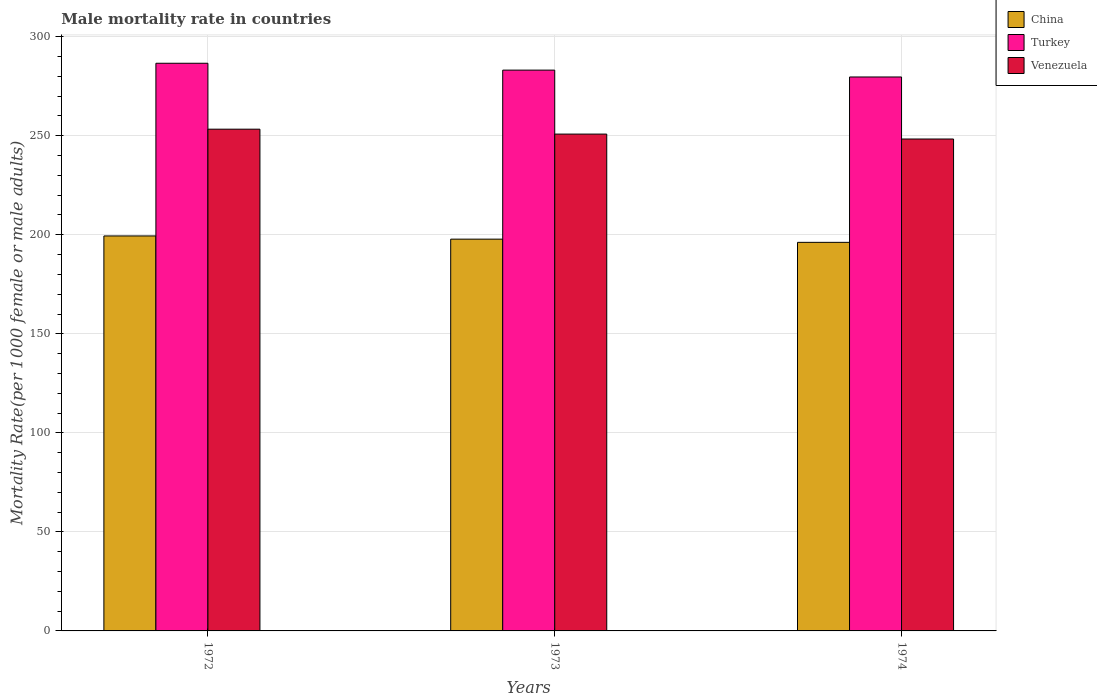Are the number of bars per tick equal to the number of legend labels?
Your response must be concise. Yes. Are the number of bars on each tick of the X-axis equal?
Your answer should be compact. Yes. How many bars are there on the 3rd tick from the left?
Provide a succinct answer. 3. What is the label of the 2nd group of bars from the left?
Your answer should be very brief. 1973. What is the male mortality rate in Turkey in 1974?
Your answer should be very brief. 279.67. Across all years, what is the maximum male mortality rate in Venezuela?
Ensure brevity in your answer.  253.31. Across all years, what is the minimum male mortality rate in China?
Your answer should be compact. 196.17. In which year was the male mortality rate in Turkey minimum?
Provide a succinct answer. 1974. What is the total male mortality rate in Venezuela in the graph?
Keep it short and to the point. 752.48. What is the difference between the male mortality rate in Venezuela in 1973 and that in 1974?
Give a very brief answer. 2.48. What is the difference between the male mortality rate in China in 1973 and the male mortality rate in Venezuela in 1974?
Ensure brevity in your answer.  -50.56. What is the average male mortality rate in China per year?
Your answer should be compact. 197.79. In the year 1973, what is the difference between the male mortality rate in Venezuela and male mortality rate in Turkey?
Provide a succinct answer. -32.3. In how many years, is the male mortality rate in Venezuela greater than 190?
Keep it short and to the point. 3. What is the ratio of the male mortality rate in China in 1973 to that in 1974?
Your answer should be very brief. 1.01. Is the difference between the male mortality rate in Venezuela in 1972 and 1973 greater than the difference between the male mortality rate in Turkey in 1972 and 1973?
Make the answer very short. No. What is the difference between the highest and the second highest male mortality rate in China?
Keep it short and to the point. 1.62. What is the difference between the highest and the lowest male mortality rate in Venezuela?
Make the answer very short. 4.96. What does the 3rd bar from the left in 1972 represents?
Offer a very short reply. Venezuela. What does the 1st bar from the right in 1973 represents?
Offer a terse response. Venezuela. Are the values on the major ticks of Y-axis written in scientific E-notation?
Provide a short and direct response. No. Does the graph contain any zero values?
Provide a succinct answer. No. Does the graph contain grids?
Your answer should be compact. Yes. Where does the legend appear in the graph?
Keep it short and to the point. Top right. How many legend labels are there?
Your response must be concise. 3. What is the title of the graph?
Your response must be concise. Male mortality rate in countries. Does "Korea (Democratic)" appear as one of the legend labels in the graph?
Offer a very short reply. No. What is the label or title of the Y-axis?
Make the answer very short. Mortality Rate(per 1000 female or male adults). What is the Mortality Rate(per 1000 female or male adults) in China in 1972?
Your answer should be compact. 199.41. What is the Mortality Rate(per 1000 female or male adults) of Turkey in 1972?
Your response must be concise. 286.59. What is the Mortality Rate(per 1000 female or male adults) of Venezuela in 1972?
Your response must be concise. 253.31. What is the Mortality Rate(per 1000 female or male adults) in China in 1973?
Offer a very short reply. 197.79. What is the Mortality Rate(per 1000 female or male adults) in Turkey in 1973?
Offer a very short reply. 283.13. What is the Mortality Rate(per 1000 female or male adults) in Venezuela in 1973?
Provide a succinct answer. 250.83. What is the Mortality Rate(per 1000 female or male adults) of China in 1974?
Your response must be concise. 196.17. What is the Mortality Rate(per 1000 female or male adults) of Turkey in 1974?
Make the answer very short. 279.67. What is the Mortality Rate(per 1000 female or male adults) of Venezuela in 1974?
Your answer should be very brief. 248.35. Across all years, what is the maximum Mortality Rate(per 1000 female or male adults) of China?
Your answer should be compact. 199.41. Across all years, what is the maximum Mortality Rate(per 1000 female or male adults) of Turkey?
Your answer should be very brief. 286.59. Across all years, what is the maximum Mortality Rate(per 1000 female or male adults) of Venezuela?
Your response must be concise. 253.31. Across all years, what is the minimum Mortality Rate(per 1000 female or male adults) in China?
Your answer should be very brief. 196.17. Across all years, what is the minimum Mortality Rate(per 1000 female or male adults) in Turkey?
Your response must be concise. 279.67. Across all years, what is the minimum Mortality Rate(per 1000 female or male adults) of Venezuela?
Your response must be concise. 248.35. What is the total Mortality Rate(per 1000 female or male adults) in China in the graph?
Your response must be concise. 593.38. What is the total Mortality Rate(per 1000 female or male adults) in Turkey in the graph?
Your response must be concise. 849.38. What is the total Mortality Rate(per 1000 female or male adults) in Venezuela in the graph?
Your response must be concise. 752.48. What is the difference between the Mortality Rate(per 1000 female or male adults) of China in 1972 and that in 1973?
Your answer should be very brief. 1.62. What is the difference between the Mortality Rate(per 1000 female or male adults) in Turkey in 1972 and that in 1973?
Your answer should be very brief. 3.46. What is the difference between the Mortality Rate(per 1000 female or male adults) in Venezuela in 1972 and that in 1973?
Provide a succinct answer. 2.48. What is the difference between the Mortality Rate(per 1000 female or male adults) of China in 1972 and that in 1974?
Ensure brevity in your answer.  3.24. What is the difference between the Mortality Rate(per 1000 female or male adults) of Turkey in 1972 and that in 1974?
Your response must be concise. 6.92. What is the difference between the Mortality Rate(per 1000 female or male adults) of Venezuela in 1972 and that in 1974?
Keep it short and to the point. 4.96. What is the difference between the Mortality Rate(per 1000 female or male adults) in China in 1973 and that in 1974?
Keep it short and to the point. 1.62. What is the difference between the Mortality Rate(per 1000 female or male adults) in Turkey in 1973 and that in 1974?
Give a very brief answer. 3.46. What is the difference between the Mortality Rate(per 1000 female or male adults) of Venezuela in 1973 and that in 1974?
Provide a succinct answer. 2.48. What is the difference between the Mortality Rate(per 1000 female or male adults) in China in 1972 and the Mortality Rate(per 1000 female or male adults) in Turkey in 1973?
Provide a short and direct response. -83.72. What is the difference between the Mortality Rate(per 1000 female or male adults) in China in 1972 and the Mortality Rate(per 1000 female or male adults) in Venezuela in 1973?
Keep it short and to the point. -51.42. What is the difference between the Mortality Rate(per 1000 female or male adults) of Turkey in 1972 and the Mortality Rate(per 1000 female or male adults) of Venezuela in 1973?
Ensure brevity in your answer.  35.76. What is the difference between the Mortality Rate(per 1000 female or male adults) in China in 1972 and the Mortality Rate(per 1000 female or male adults) in Turkey in 1974?
Your answer should be compact. -80.26. What is the difference between the Mortality Rate(per 1000 female or male adults) in China in 1972 and the Mortality Rate(per 1000 female or male adults) in Venezuela in 1974?
Your answer should be compact. -48.94. What is the difference between the Mortality Rate(per 1000 female or male adults) in Turkey in 1972 and the Mortality Rate(per 1000 female or male adults) in Venezuela in 1974?
Provide a short and direct response. 38.24. What is the difference between the Mortality Rate(per 1000 female or male adults) in China in 1973 and the Mortality Rate(per 1000 female or male adults) in Turkey in 1974?
Keep it short and to the point. -81.87. What is the difference between the Mortality Rate(per 1000 female or male adults) in China in 1973 and the Mortality Rate(per 1000 female or male adults) in Venezuela in 1974?
Provide a short and direct response. -50.56. What is the difference between the Mortality Rate(per 1000 female or male adults) of Turkey in 1973 and the Mortality Rate(per 1000 female or male adults) of Venezuela in 1974?
Ensure brevity in your answer.  34.78. What is the average Mortality Rate(per 1000 female or male adults) of China per year?
Your answer should be very brief. 197.79. What is the average Mortality Rate(per 1000 female or male adults) of Turkey per year?
Give a very brief answer. 283.13. What is the average Mortality Rate(per 1000 female or male adults) of Venezuela per year?
Give a very brief answer. 250.83. In the year 1972, what is the difference between the Mortality Rate(per 1000 female or male adults) of China and Mortality Rate(per 1000 female or male adults) of Turkey?
Your response must be concise. -87.18. In the year 1972, what is the difference between the Mortality Rate(per 1000 female or male adults) of China and Mortality Rate(per 1000 female or male adults) of Venezuela?
Provide a short and direct response. -53.9. In the year 1972, what is the difference between the Mortality Rate(per 1000 female or male adults) in Turkey and Mortality Rate(per 1000 female or male adults) in Venezuela?
Provide a short and direct response. 33.28. In the year 1973, what is the difference between the Mortality Rate(per 1000 female or male adults) in China and Mortality Rate(per 1000 female or male adults) in Turkey?
Provide a succinct answer. -85.34. In the year 1973, what is the difference between the Mortality Rate(per 1000 female or male adults) of China and Mortality Rate(per 1000 female or male adults) of Venezuela?
Provide a short and direct response. -53.04. In the year 1973, what is the difference between the Mortality Rate(per 1000 female or male adults) in Turkey and Mortality Rate(per 1000 female or male adults) in Venezuela?
Ensure brevity in your answer.  32.3. In the year 1974, what is the difference between the Mortality Rate(per 1000 female or male adults) in China and Mortality Rate(per 1000 female or male adults) in Turkey?
Keep it short and to the point. -83.49. In the year 1974, what is the difference between the Mortality Rate(per 1000 female or male adults) of China and Mortality Rate(per 1000 female or male adults) of Venezuela?
Give a very brief answer. -52.17. In the year 1974, what is the difference between the Mortality Rate(per 1000 female or male adults) of Turkey and Mortality Rate(per 1000 female or male adults) of Venezuela?
Ensure brevity in your answer.  31.32. What is the ratio of the Mortality Rate(per 1000 female or male adults) of China in 1972 to that in 1973?
Make the answer very short. 1.01. What is the ratio of the Mortality Rate(per 1000 female or male adults) of Turkey in 1972 to that in 1973?
Offer a very short reply. 1.01. What is the ratio of the Mortality Rate(per 1000 female or male adults) in Venezuela in 1972 to that in 1973?
Offer a terse response. 1.01. What is the ratio of the Mortality Rate(per 1000 female or male adults) of China in 1972 to that in 1974?
Offer a very short reply. 1.02. What is the ratio of the Mortality Rate(per 1000 female or male adults) in Turkey in 1972 to that in 1974?
Your answer should be very brief. 1.02. What is the ratio of the Mortality Rate(per 1000 female or male adults) in Venezuela in 1972 to that in 1974?
Offer a terse response. 1.02. What is the ratio of the Mortality Rate(per 1000 female or male adults) of China in 1973 to that in 1974?
Your answer should be compact. 1.01. What is the ratio of the Mortality Rate(per 1000 female or male adults) in Turkey in 1973 to that in 1974?
Make the answer very short. 1.01. What is the ratio of the Mortality Rate(per 1000 female or male adults) in Venezuela in 1973 to that in 1974?
Offer a terse response. 1.01. What is the difference between the highest and the second highest Mortality Rate(per 1000 female or male adults) in China?
Keep it short and to the point. 1.62. What is the difference between the highest and the second highest Mortality Rate(per 1000 female or male adults) in Turkey?
Your response must be concise. 3.46. What is the difference between the highest and the second highest Mortality Rate(per 1000 female or male adults) in Venezuela?
Provide a succinct answer. 2.48. What is the difference between the highest and the lowest Mortality Rate(per 1000 female or male adults) in China?
Make the answer very short. 3.24. What is the difference between the highest and the lowest Mortality Rate(per 1000 female or male adults) of Turkey?
Keep it short and to the point. 6.92. What is the difference between the highest and the lowest Mortality Rate(per 1000 female or male adults) in Venezuela?
Give a very brief answer. 4.96. 